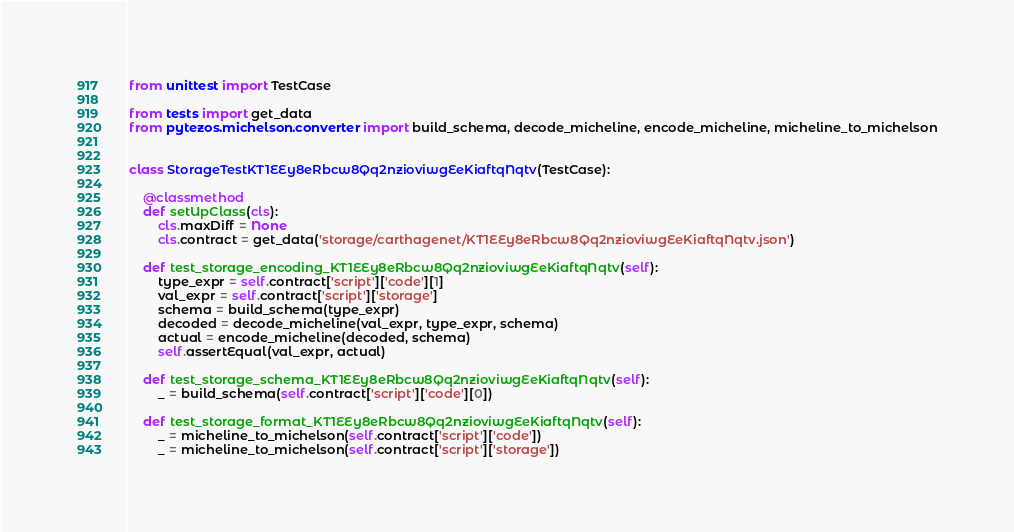<code> <loc_0><loc_0><loc_500><loc_500><_Python_>from unittest import TestCase

from tests import get_data
from pytezos.michelson.converter import build_schema, decode_micheline, encode_micheline, micheline_to_michelson


class StorageTestKT1EEy8eRbcw8Qq2nzioviwgEeKiaftqNqtv(TestCase):

    @classmethod
    def setUpClass(cls):
        cls.maxDiff = None
        cls.contract = get_data('storage/carthagenet/KT1EEy8eRbcw8Qq2nzioviwgEeKiaftqNqtv.json')

    def test_storage_encoding_KT1EEy8eRbcw8Qq2nzioviwgEeKiaftqNqtv(self):
        type_expr = self.contract['script']['code'][1]
        val_expr = self.contract['script']['storage']
        schema = build_schema(type_expr)
        decoded = decode_micheline(val_expr, type_expr, schema)
        actual = encode_micheline(decoded, schema)
        self.assertEqual(val_expr, actual)

    def test_storage_schema_KT1EEy8eRbcw8Qq2nzioviwgEeKiaftqNqtv(self):
        _ = build_schema(self.contract['script']['code'][0])

    def test_storage_format_KT1EEy8eRbcw8Qq2nzioviwgEeKiaftqNqtv(self):
        _ = micheline_to_michelson(self.contract['script']['code'])
        _ = micheline_to_michelson(self.contract['script']['storage'])
</code> 